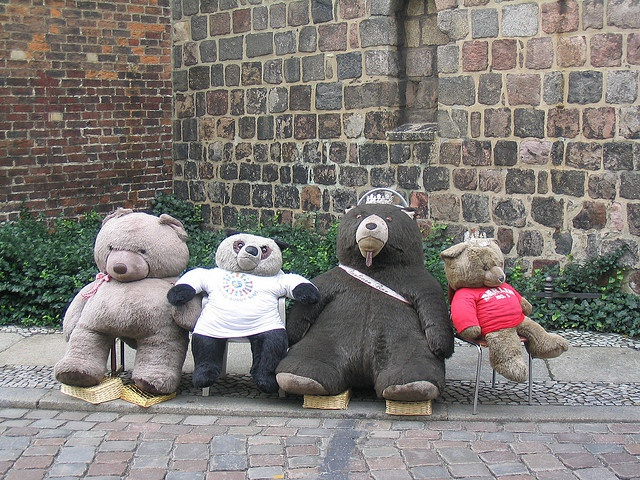Describe the objects in this image and their specific colors. I can see teddy bear in gray, black, darkgray, and lightgray tones, teddy bear in gray, darkgray, lightgray, and black tones, teddy bear in gray, white, and black tones, teddy bear in gray, darkgray, salmon, and brown tones, and chair in gray, darkgray, black, and maroon tones in this image. 